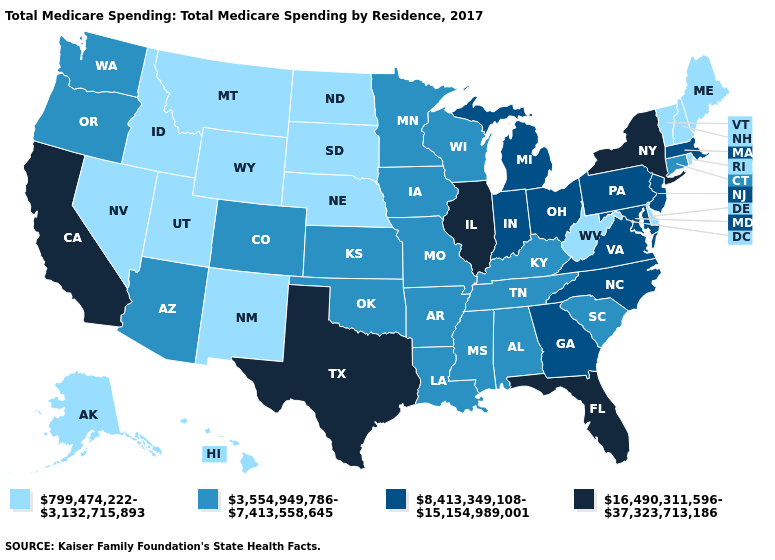Among the states that border Arkansas , which have the highest value?
Keep it brief. Texas. Name the states that have a value in the range 3,554,949,786-7,413,558,645?
Give a very brief answer. Alabama, Arizona, Arkansas, Colorado, Connecticut, Iowa, Kansas, Kentucky, Louisiana, Minnesota, Mississippi, Missouri, Oklahoma, Oregon, South Carolina, Tennessee, Washington, Wisconsin. What is the lowest value in the MidWest?
Write a very short answer. 799,474,222-3,132,715,893. Name the states that have a value in the range 16,490,311,596-37,323,713,186?
Give a very brief answer. California, Florida, Illinois, New York, Texas. What is the value of Connecticut?
Write a very short answer. 3,554,949,786-7,413,558,645. What is the highest value in states that border Oklahoma?
Quick response, please. 16,490,311,596-37,323,713,186. What is the highest value in the USA?
Keep it brief. 16,490,311,596-37,323,713,186. What is the lowest value in the USA?
Give a very brief answer. 799,474,222-3,132,715,893. Does California have the highest value in the West?
Concise answer only. Yes. What is the highest value in the USA?
Concise answer only. 16,490,311,596-37,323,713,186. Does Arkansas have the same value as Virginia?
Keep it brief. No. Does New York have the highest value in the USA?
Be succinct. Yes. Does the first symbol in the legend represent the smallest category?
Write a very short answer. Yes. What is the lowest value in the Northeast?
Give a very brief answer. 799,474,222-3,132,715,893. What is the value of Texas?
Write a very short answer. 16,490,311,596-37,323,713,186. 